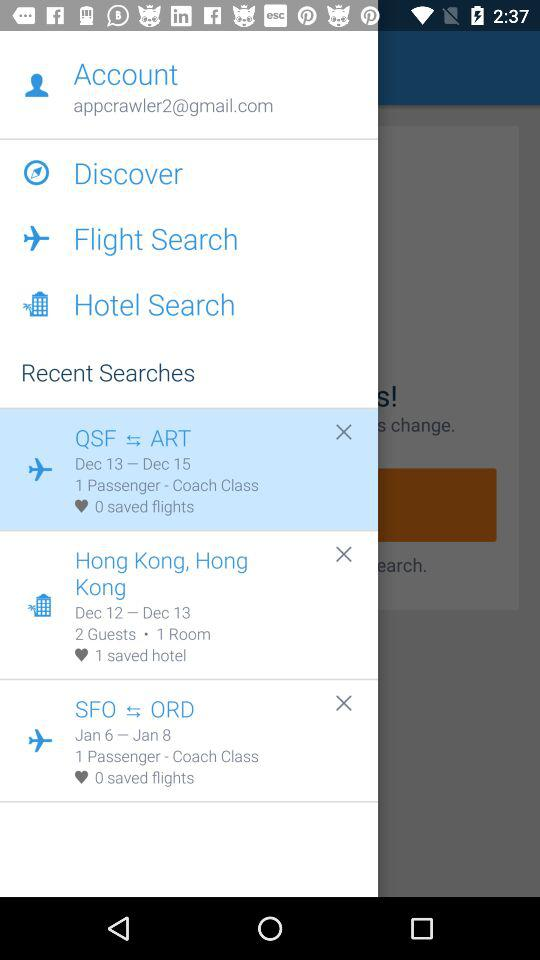How many saved hotel searches are there?
Answer the question using a single word or phrase. 1 